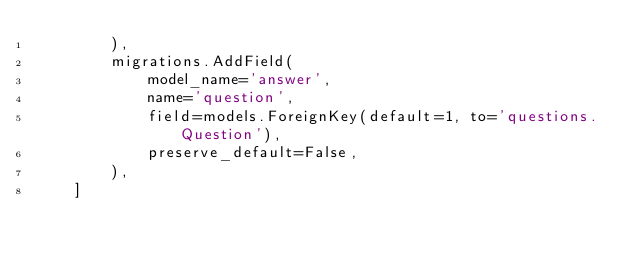<code> <loc_0><loc_0><loc_500><loc_500><_Python_>        ),
        migrations.AddField(
            model_name='answer',
            name='question',
            field=models.ForeignKey(default=1, to='questions.Question'),
            preserve_default=False,
        ),
    ]
</code> 